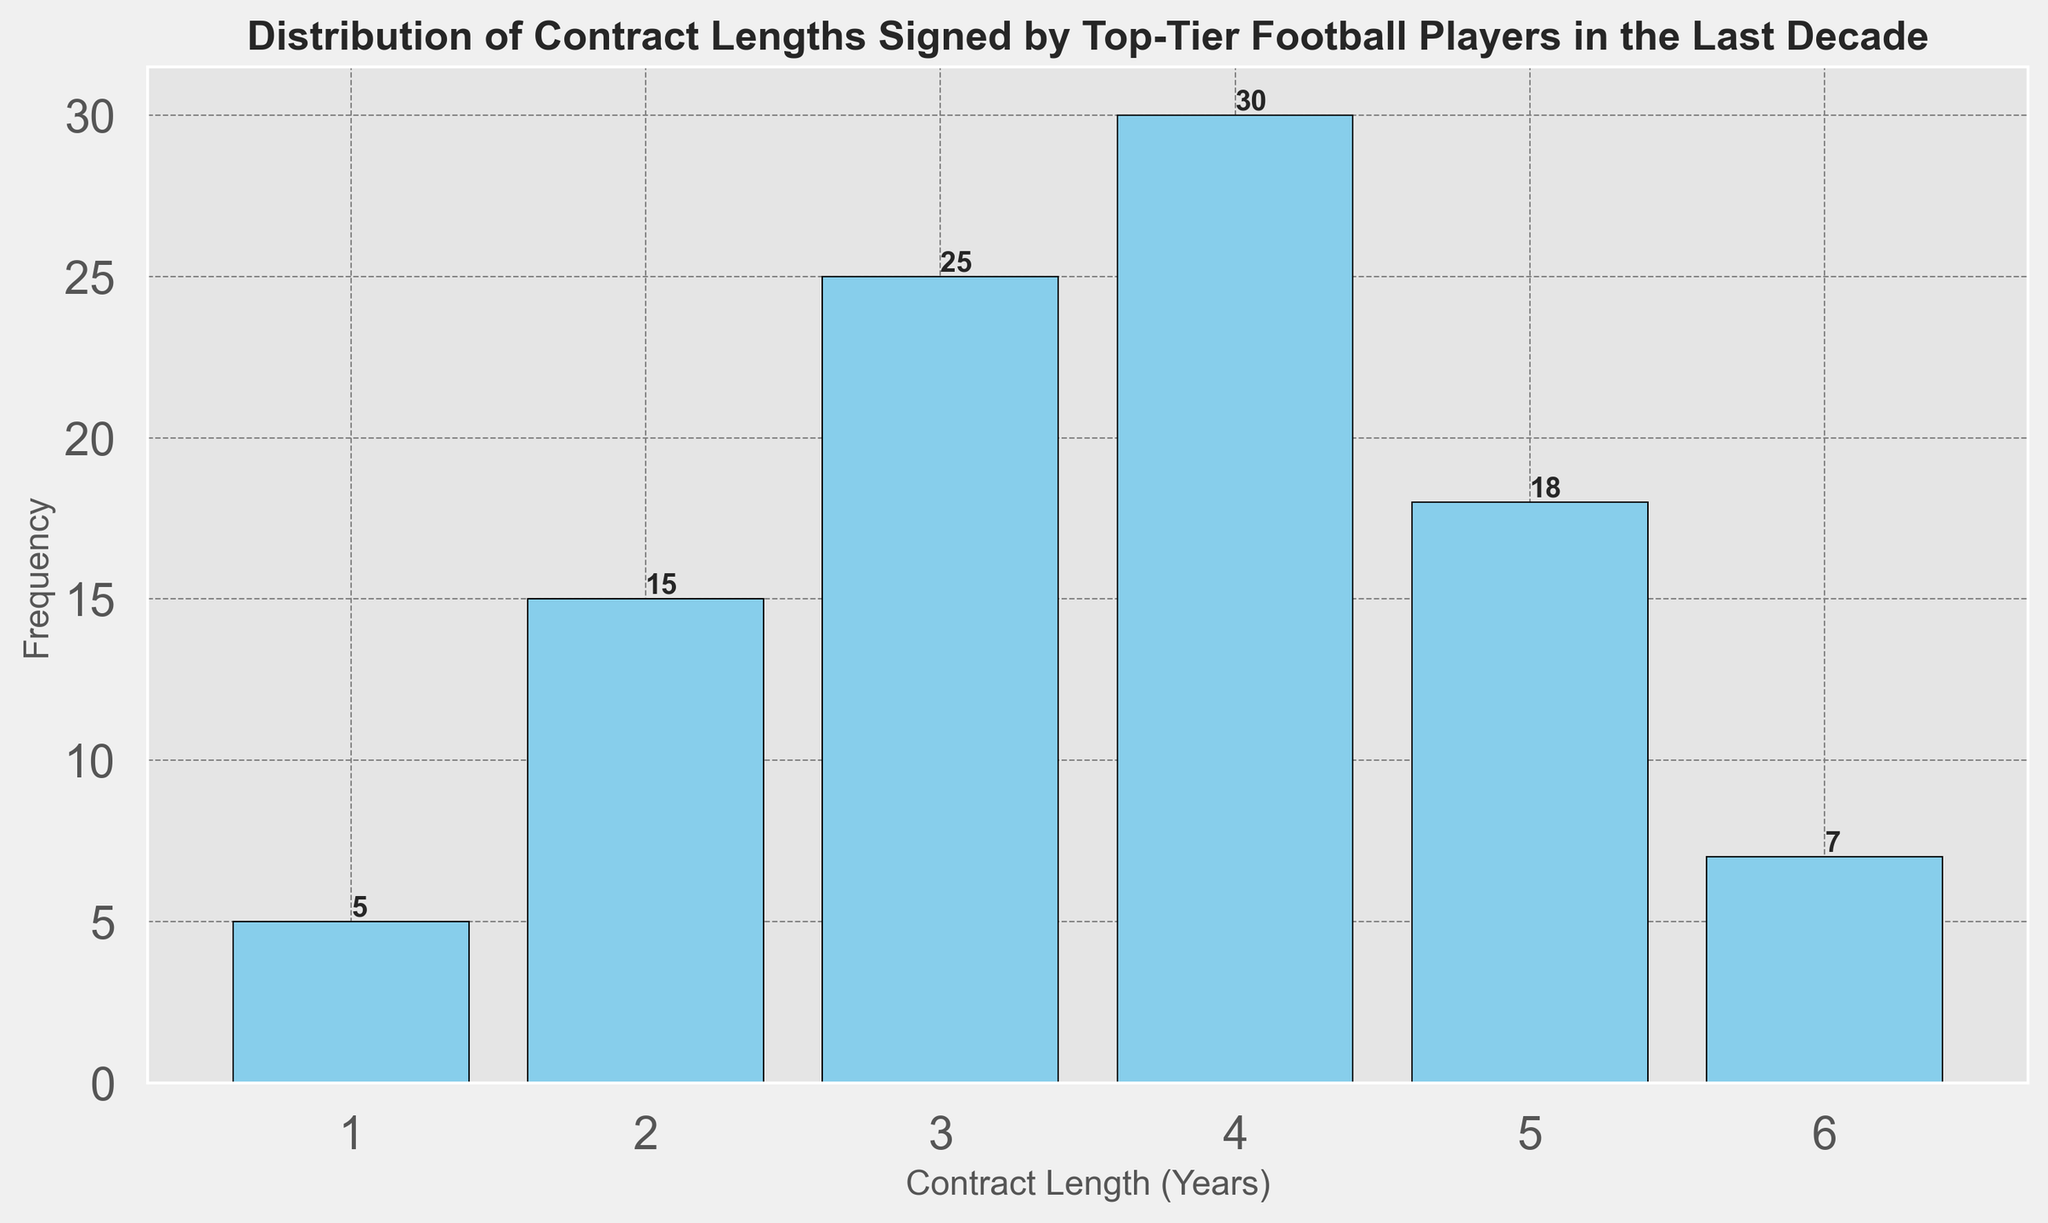What is the most common contract length signed by top-tier football players in the last decade? By observing the bar chart, the tallest bar represents the most common contract length. The contract length with the highest frequency is 4 years.
Answer: 4 years Which contract length has the least frequency, and how often is it signed? The shortest bar indicates the least common contract length. The 1-year contract has the lowest frequency at 5 signings.
Answer: 1 year, 5 signings How many players in total signed contracts of 3 years or less? Summing the frequencies of the contract lengths 1, 2, and 3 years: 5 (1-year) + 15 (2-year) + 25 (3-year) = 45 players.
Answer: 45 players What is the difference in frequency between the most common and the least common contract lengths? The most common contract length (4 years) has a frequency of 30, and the least common (1 year) has a frequency of 5. The difference is 30 - 5 = 25.
Answer: 25 Which contract lengths are signed more frequently than a 5-year contract? Observing the bars taller than the 5-year contract bar (frequency 18), the 3-year (25) and 4-year (30) contract lengths are signed more frequently.
Answer: 3 and 4 years What is the sum of the frequencies for contract lengths of 4 years and 5 years? Adding the frequencies of the 4-year and 5-year contracts: 30 (4-year) + 18 (5-year) = 48.
Answer: 48 Are there more players signing 2-year contracts or 5-year contracts? By comparing the heights of the bars, the 2-year contract (15 signings) is less than the 5-year contract (18 signings).
Answer: 5-year contracts How many players signed contracts that are at most 2 years in length? Summing the frequencies of the contract lengths 1 and 2 years: 5 (1-year) + 15 (2-year) = 20 players.
Answer: 20 players Which is greater: the frequency of 3-year contracts or the sum of frequencies of 1-year and 6-year contracts? The frequency of 3-year contracts is 25, while the sum of 1-year and 6-year contracts is 5 + 7 = 12. Therefore, the frequency of 3-year contracts (25) is greater.
Answer: 3-year contracts 